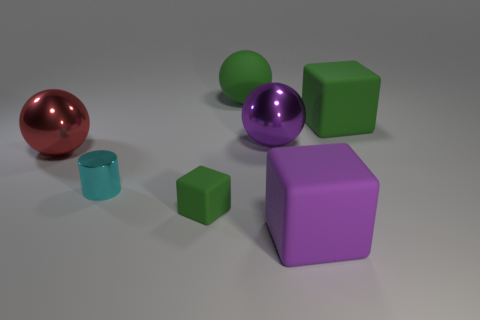There is a metal thing to the right of the tiny rubber block; what color is it?
Your answer should be very brief. Purple. Are there the same number of big purple metallic objects in front of the small rubber object and big purple objects behind the green matte sphere?
Provide a succinct answer. Yes. There is a purple object that is in front of the big sphere that is left of the green matte ball; what is it made of?
Ensure brevity in your answer.  Rubber. How many things are either tiny cylinders or metal things that are left of the matte ball?
Your answer should be compact. 2. What is the size of the cylinder that is the same material as the big purple ball?
Make the answer very short. Small. Are there more small green objects left of the big red shiny ball than red balls?
Give a very brief answer. No. There is a thing that is to the right of the tiny green matte block and in front of the cylinder; how big is it?
Ensure brevity in your answer.  Large. What material is the other tiny object that is the same shape as the purple rubber thing?
Keep it short and to the point. Rubber. There is a metal sphere that is behind the red object; is its size the same as the green sphere?
Give a very brief answer. Yes. There is a matte object that is in front of the big green rubber sphere and to the left of the purple rubber object; what is its color?
Keep it short and to the point. Green. 